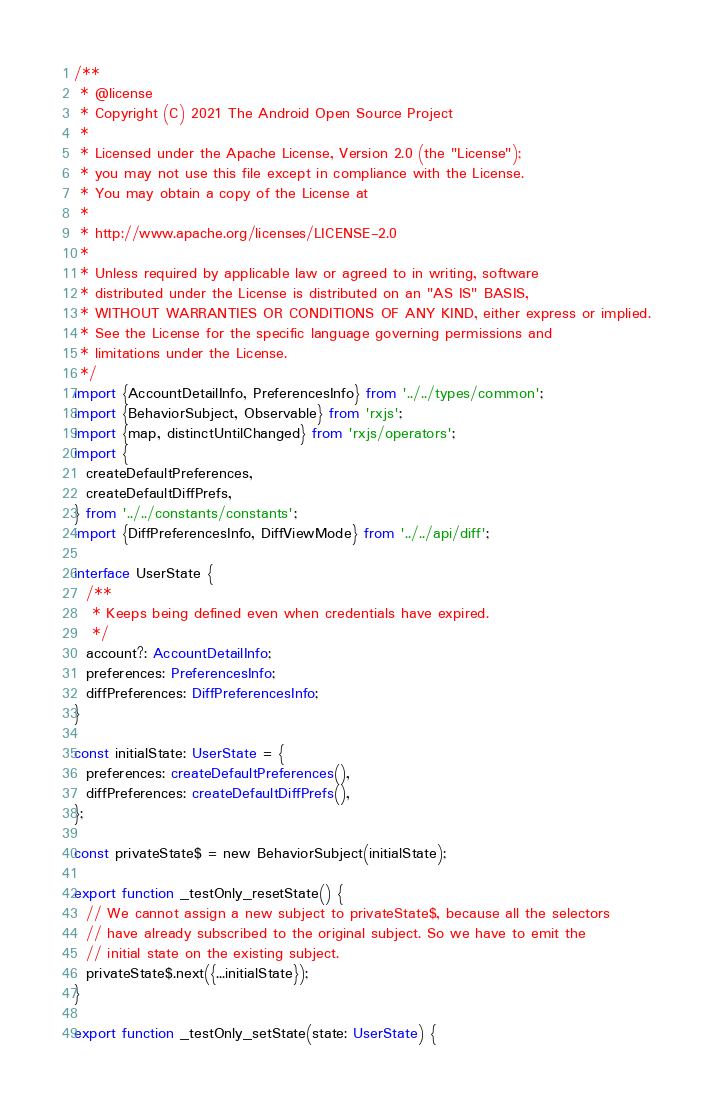<code> <loc_0><loc_0><loc_500><loc_500><_TypeScript_>/**
 * @license
 * Copyright (C) 2021 The Android Open Source Project
 *
 * Licensed under the Apache License, Version 2.0 (the "License");
 * you may not use this file except in compliance with the License.
 * You may obtain a copy of the License at
 *
 * http://www.apache.org/licenses/LICENSE-2.0
 *
 * Unless required by applicable law or agreed to in writing, software
 * distributed under the License is distributed on an "AS IS" BASIS,
 * WITHOUT WARRANTIES OR CONDITIONS OF ANY KIND, either express or implied.
 * See the License for the specific language governing permissions and
 * limitations under the License.
 */
import {AccountDetailInfo, PreferencesInfo} from '../../types/common';
import {BehaviorSubject, Observable} from 'rxjs';
import {map, distinctUntilChanged} from 'rxjs/operators';
import {
  createDefaultPreferences,
  createDefaultDiffPrefs,
} from '../../constants/constants';
import {DiffPreferencesInfo, DiffViewMode} from '../../api/diff';

interface UserState {
  /**
   * Keeps being defined even when credentials have expired.
   */
  account?: AccountDetailInfo;
  preferences: PreferencesInfo;
  diffPreferences: DiffPreferencesInfo;
}

const initialState: UserState = {
  preferences: createDefaultPreferences(),
  diffPreferences: createDefaultDiffPrefs(),
};

const privateState$ = new BehaviorSubject(initialState);

export function _testOnly_resetState() {
  // We cannot assign a new subject to privateState$, because all the selectors
  // have already subscribed to the original subject. So we have to emit the
  // initial state on the existing subject.
  privateState$.next({...initialState});
}

export function _testOnly_setState(state: UserState) {</code> 